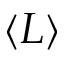<formula> <loc_0><loc_0><loc_500><loc_500>\langle L \rangle</formula> 